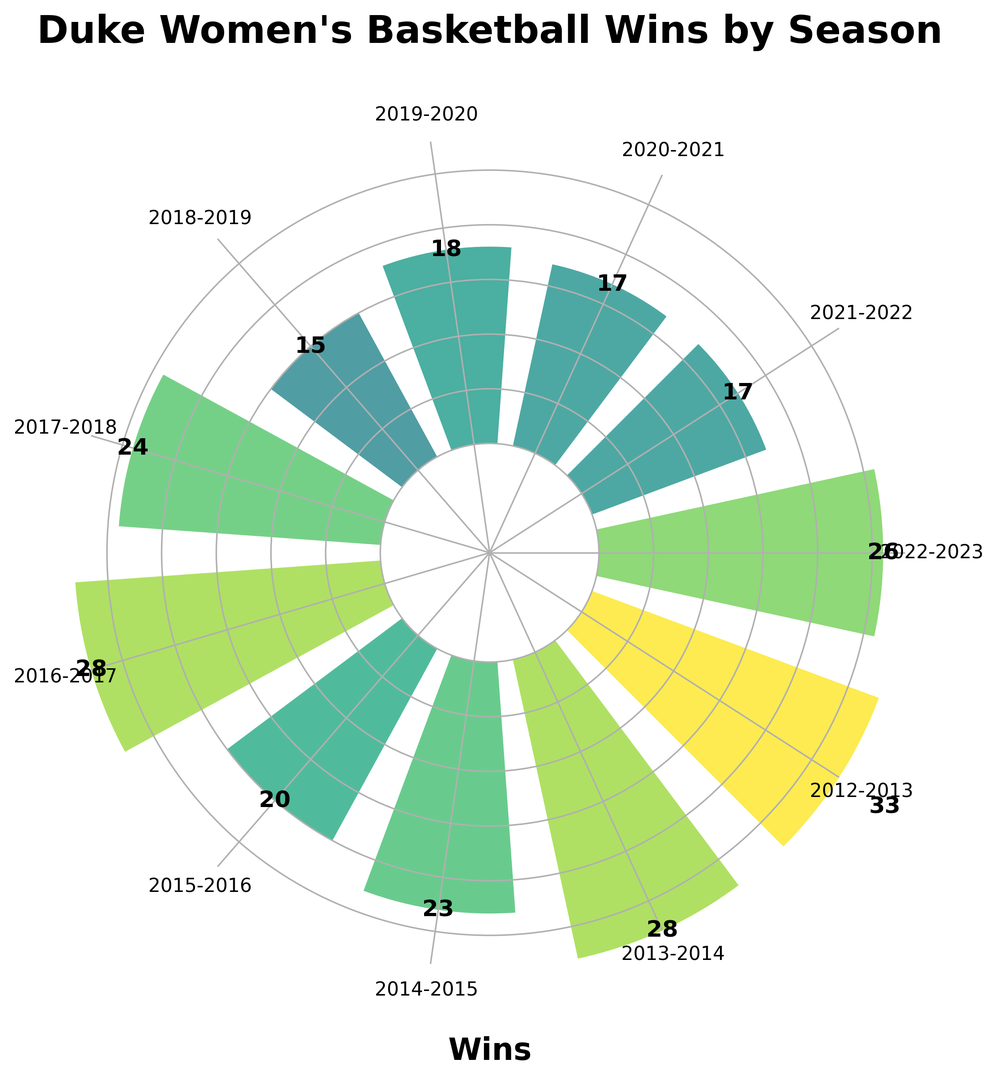What's the total number of wins for the past decade? Add the wins for all seasons: 26 + 17 + 17 + 18 + 15 + 24 + 28 + 20 + 23 + 28 + 33 = 249
Answer: 249 Which season has the highest number of wins? Look for the tallest bar in the ring chart and read the label. The highest bar corresponds to the 2012-2013 season with 33 wins.
Answer: 2012-2013 How many seasons had 20 or more wins? Count the number of bars (representing seasons) that have a height of 20 or more. There are 6 seasons: 2022-2023, 2017-2018, 2016-2017, 2015-2016, 2014-2015, and 2012-2013.
Answer: 6 What is the average number of wins per season? Sum of wins is 249. Number of seasons is 11. The average is 249 / 11 ≈ 22.64
Answer: 22.64 Which season had the fewest wins? Identify the shortest bar in the ring chart and read the label. The shortest bar corresponds to the 2018-2019 season with 15 wins.
Answer: 2018-2019 Is the number of wins in the 2016-2017 season greater than in the 2013-2014 season? Compare the heights of the bars for these two seasons. Both bars have the same height, indicating 28 wins each.
Answer: No What's the range of wins across all seasons? Find the difference between the highest (33 wins in 2012-2013) and the lowest (15 wins in 2018-2019). The range is 33 - 15 = 18
Answer: 18 What is the median number of wins across the past decade? List all win values: 15, 17, 17, 18, 20, 23, 24, 26, 28, 28, 33. The median is the middle value when ordered, which is 23 for these 11 numbers.
Answer: 23 How many more wins were there in the 2022-2023 season compared to the 2018-2019 season? The difference between 2022-2023 (26 wins) and 2018-2019 (15 wins) is 26 - 15 = 11
Answer: 11 What percentage of the total wins did the 2012-2013 season contribute? Total wins is 249. The 2012-2013 season had 33 wins. The percentage is (33/249) * 100 ≈ 13.25%
Answer: 13.25% 